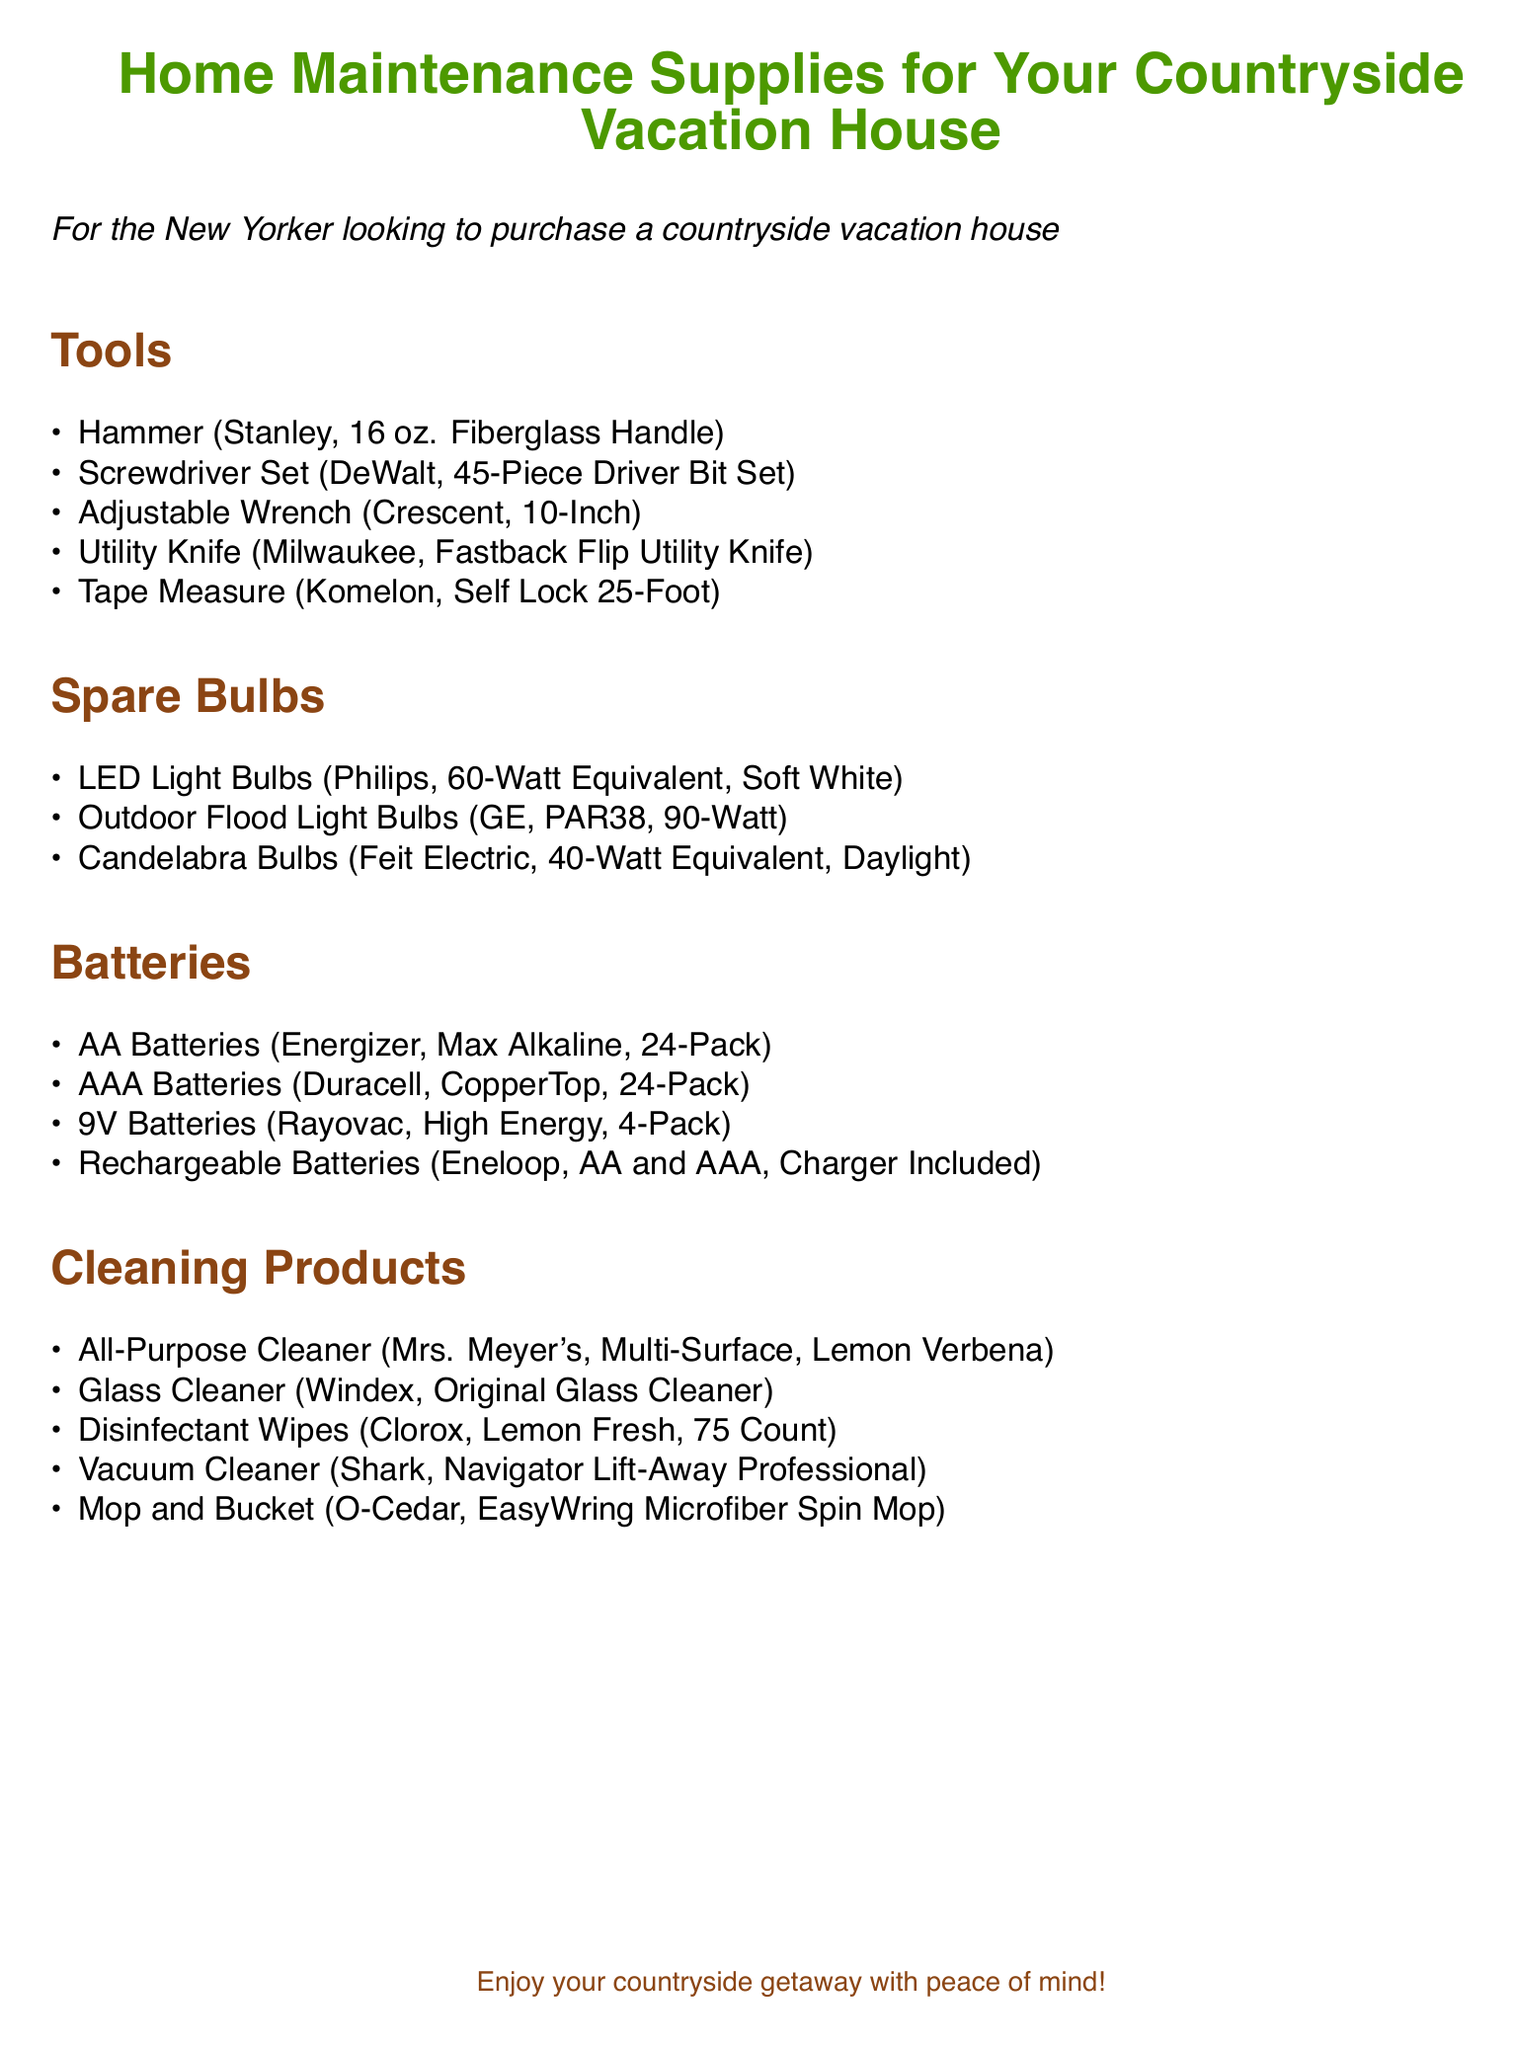What type of adjustable wrench is recommended? The document specifies the brand and size of the adjustable wrench, which is Crescent, 10-Inch.
Answer: Crescent, 10-Inch How many LED light bulbs are listed? The section for spare bulbs lists three types of bulbs, with only one type being LED, which is stated explicitly.
Answer: 1 What is the total count of AA batteries included? The document states the pack size of the AA batteries, which is 24-Pack.
Answer: 24-Pack What brand of vacuum cleaner is suggested? The document provides the brand name for the vacuum cleaner, which is Shark.
Answer: Shark Which cleaning product type is noted first? The order of the cleaning products starts with All-Purpose Cleaner.
Answer: All-Purpose Cleaner How many items are listed under Tools? There are five tools enumerated in the Tools section of the document.
Answer: 5 What is the wattage equivalent of the candelabra bulbs? The document explicitly specifies that the candelabra bulbs are 40-Watt Equivalent.
Answer: 40-Watt Equivalent Which brand sells the disinfectant wipes? The document names Clorox as the brand for the disinfectant wipes.
Answer: Clorox What is the color theme used in the title? The document mentions the colors used in the title, emphasizing rustic brown for the title text.
Answer: rustic brown 